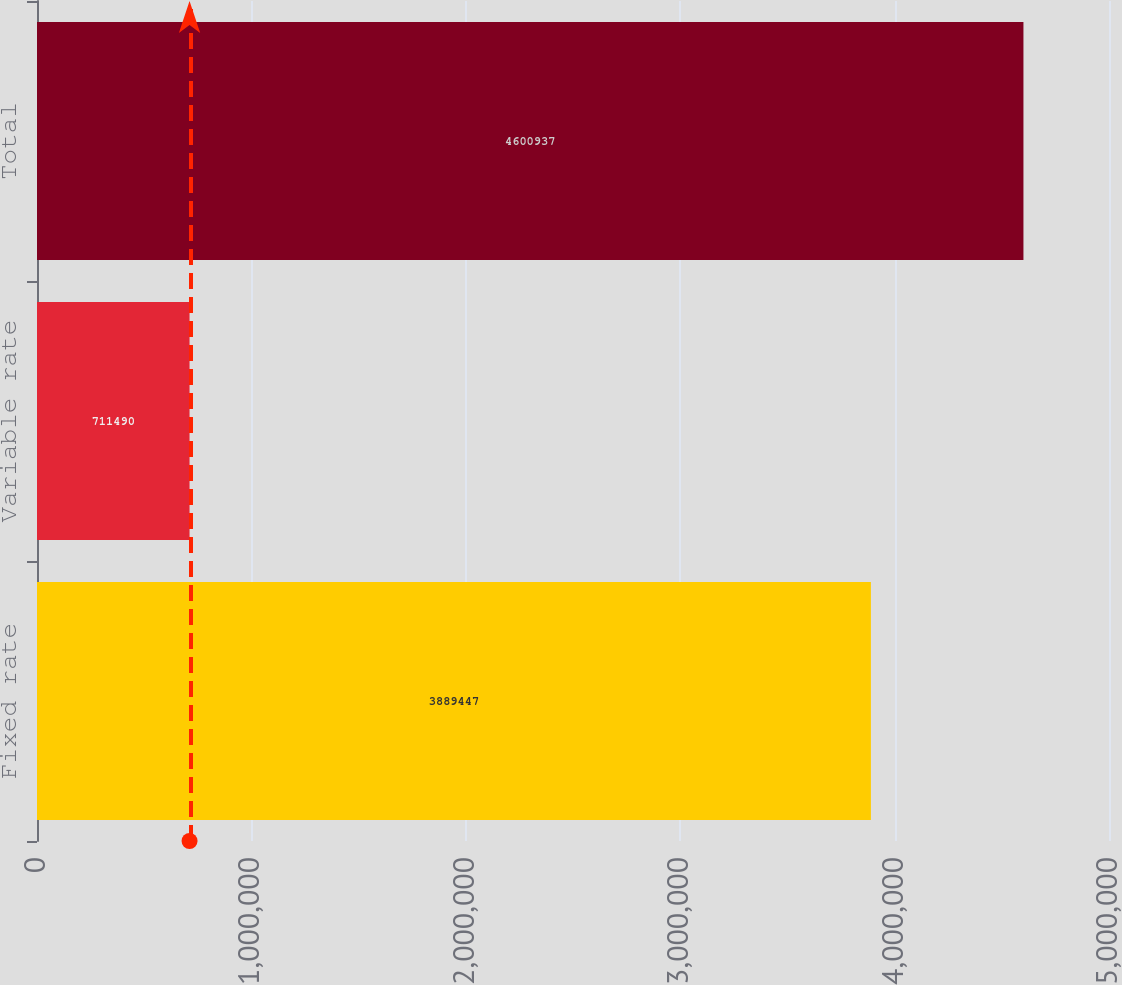Convert chart. <chart><loc_0><loc_0><loc_500><loc_500><bar_chart><fcel>Fixed rate<fcel>Variable rate<fcel>Total<nl><fcel>3.88945e+06<fcel>711490<fcel>4.60094e+06<nl></chart> 